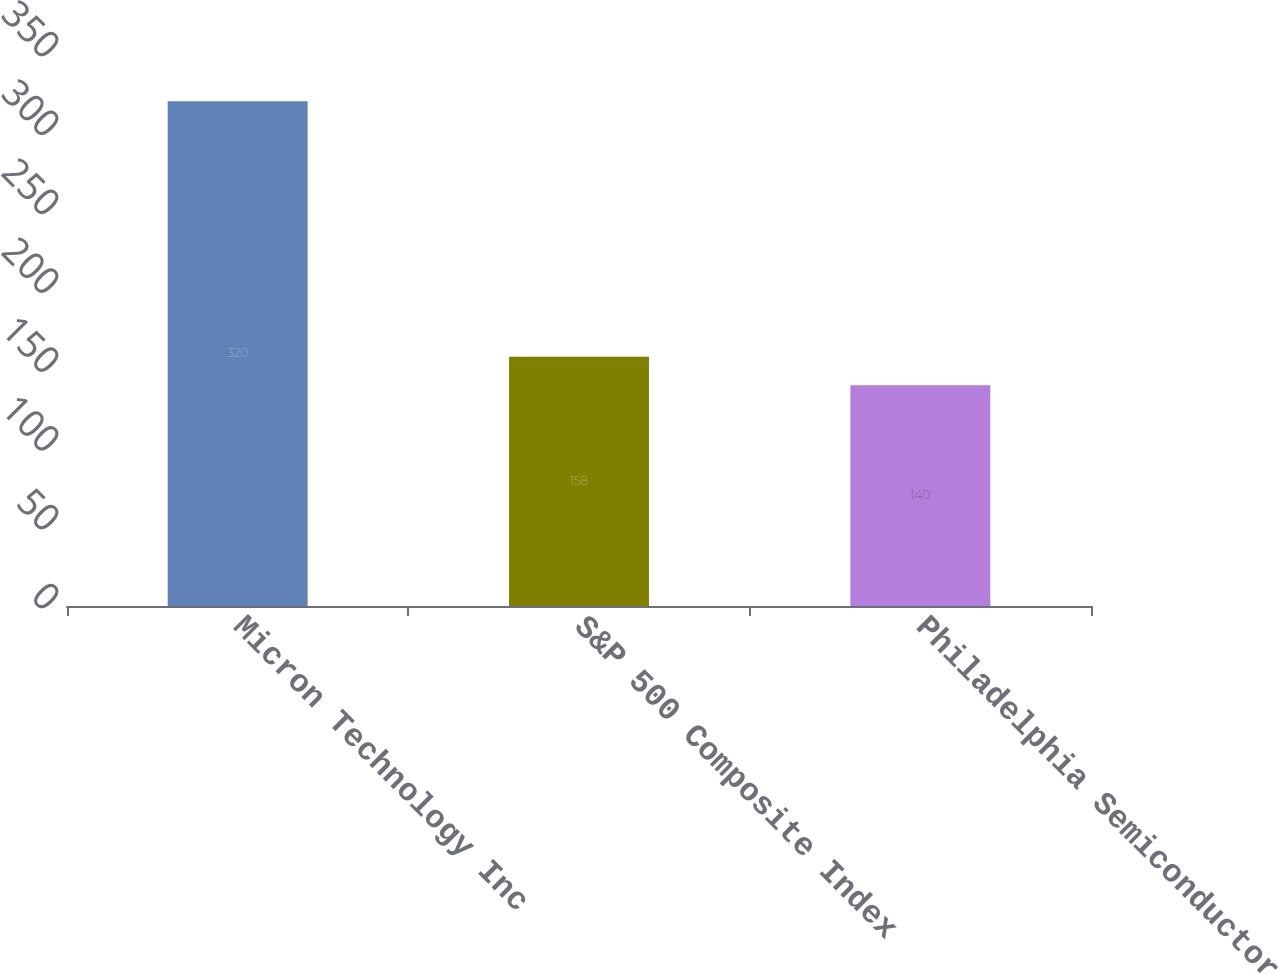<chart> <loc_0><loc_0><loc_500><loc_500><bar_chart><fcel>Micron Technology Inc<fcel>S&P 500 Composite Index<fcel>Philadelphia Semiconductor<nl><fcel>320<fcel>158<fcel>140<nl></chart> 